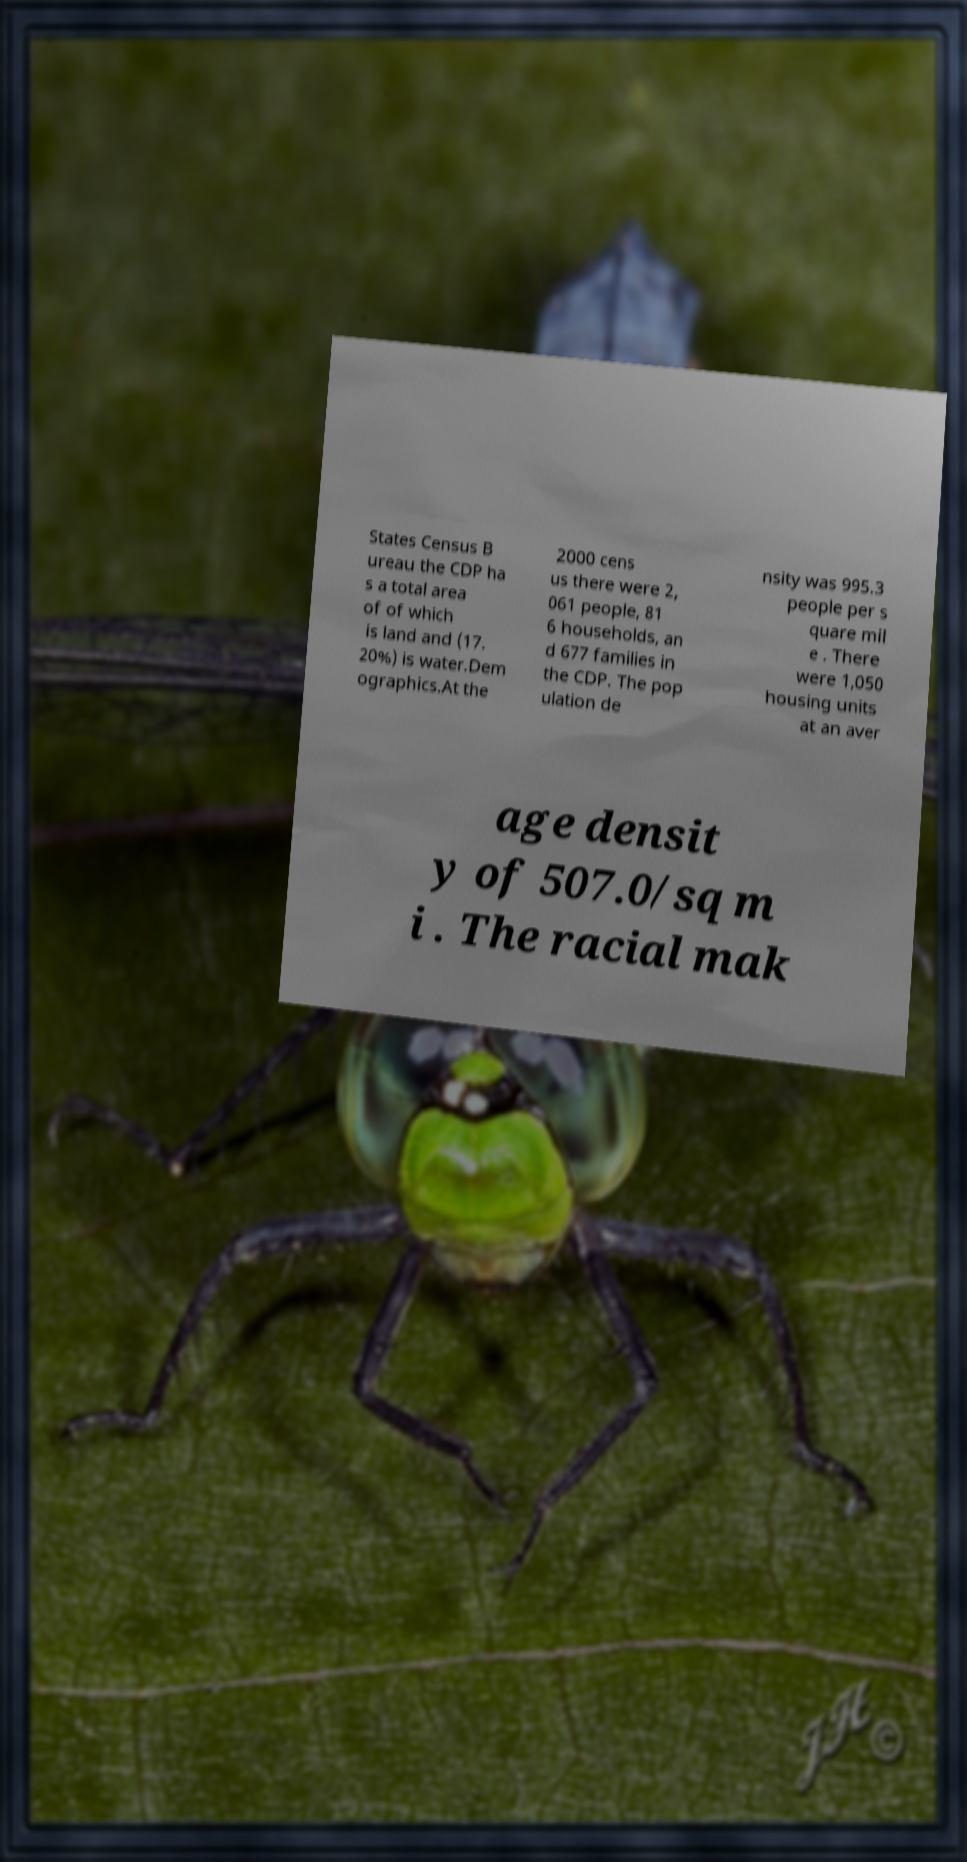Please read and relay the text visible in this image. What does it say? States Census B ureau the CDP ha s a total area of of which is land and (17. 20%) is water.Dem ographics.At the 2000 cens us there were 2, 061 people, 81 6 households, an d 677 families in the CDP. The pop ulation de nsity was 995.3 people per s quare mil e . There were 1,050 housing units at an aver age densit y of 507.0/sq m i . The racial mak 